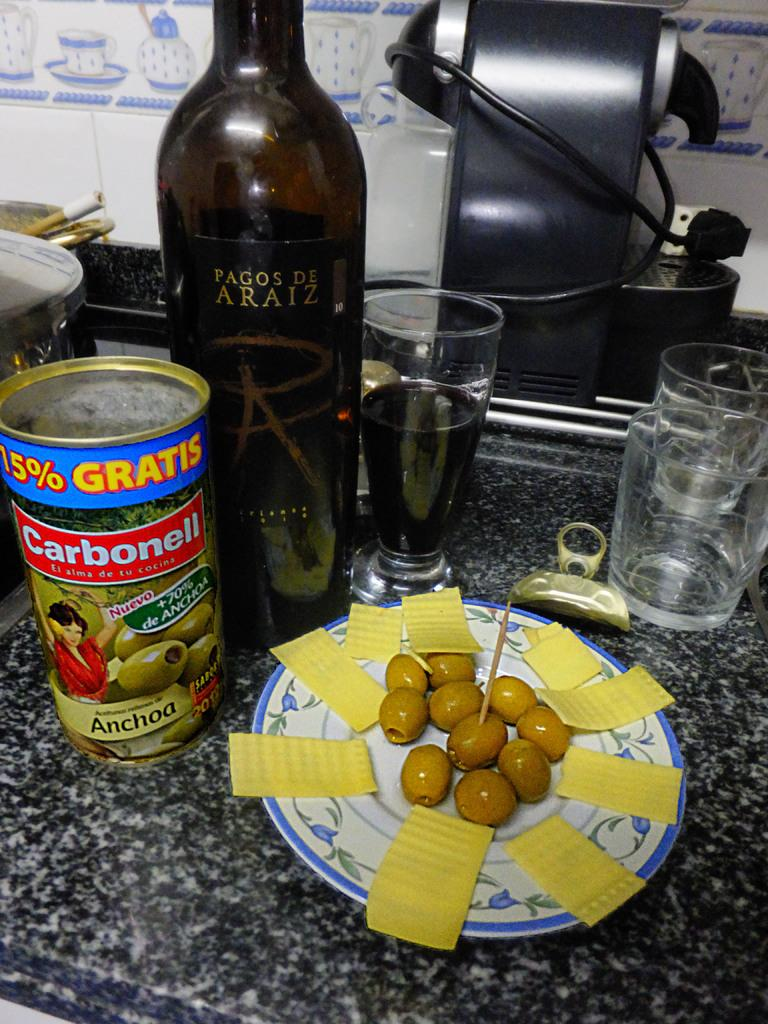What can be seen in the image that is used for holding liquids? There is a bottle in the image that is used for holding liquids. What else is present in the image that might be used for eating or drinking? There is food, a plate, and glasses visible in the image. Can you describe the objects on the surface in the image? Yes, there are objects on the surface in the image, including the bottle, food, plate, and glasses. What can be seen in the background of the image? There is a wall visible in the background of the image. What season is depicted in the image? The provided facts do not mention any season or weather-related details, so it cannot be determined from the image. What shape is the food on the plate in the image? The provided facts do not mention the shape of the food on the plate, so it cannot be determined from the image. 